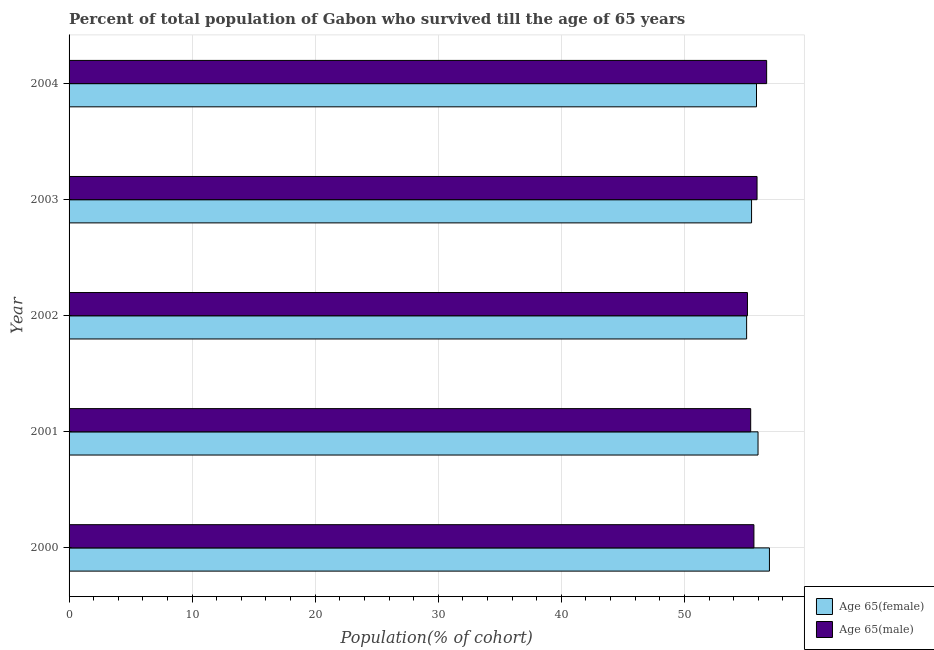How many different coloured bars are there?
Your answer should be compact. 2. How many groups of bars are there?
Provide a succinct answer. 5. Are the number of bars on each tick of the Y-axis equal?
Keep it short and to the point. Yes. How many bars are there on the 2nd tick from the bottom?
Provide a succinct answer. 2. What is the label of the 2nd group of bars from the top?
Give a very brief answer. 2003. In how many cases, is the number of bars for a given year not equal to the number of legend labels?
Provide a short and direct response. 0. What is the percentage of male population who survived till age of 65 in 2001?
Offer a very short reply. 55.39. Across all years, what is the maximum percentage of male population who survived till age of 65?
Offer a very short reply. 56.68. Across all years, what is the minimum percentage of male population who survived till age of 65?
Offer a terse response. 55.13. What is the total percentage of female population who survived till age of 65 in the graph?
Your response must be concise. 279.27. What is the difference between the percentage of male population who survived till age of 65 in 2000 and that in 2002?
Provide a short and direct response. 0.53. What is the difference between the percentage of female population who survived till age of 65 in 2004 and the percentage of male population who survived till age of 65 in 2003?
Your response must be concise. -0.04. What is the average percentage of male population who survived till age of 65 per year?
Your answer should be very brief. 55.75. In the year 2001, what is the difference between the percentage of female population who survived till age of 65 and percentage of male population who survived till age of 65?
Your answer should be very brief. 0.6. What is the ratio of the percentage of male population who survived till age of 65 in 2000 to that in 2004?
Offer a terse response. 0.98. Is the percentage of male population who survived till age of 65 in 2001 less than that in 2004?
Provide a short and direct response. Yes. Is the difference between the percentage of male population who survived till age of 65 in 2001 and 2004 greater than the difference between the percentage of female population who survived till age of 65 in 2001 and 2004?
Ensure brevity in your answer.  No. What is the difference between the highest and the second highest percentage of male population who survived till age of 65?
Your answer should be compact. 0.78. What is the difference between the highest and the lowest percentage of female population who survived till age of 65?
Keep it short and to the point. 1.85. In how many years, is the percentage of female population who survived till age of 65 greater than the average percentage of female population who survived till age of 65 taken over all years?
Your response must be concise. 3. What does the 2nd bar from the top in 2000 represents?
Your answer should be very brief. Age 65(female). What does the 1st bar from the bottom in 2003 represents?
Offer a very short reply. Age 65(female). Are all the bars in the graph horizontal?
Offer a terse response. Yes. What is the difference between two consecutive major ticks on the X-axis?
Make the answer very short. 10. Are the values on the major ticks of X-axis written in scientific E-notation?
Give a very brief answer. No. How many legend labels are there?
Give a very brief answer. 2. What is the title of the graph?
Give a very brief answer. Percent of total population of Gabon who survived till the age of 65 years. Does "State government" appear as one of the legend labels in the graph?
Keep it short and to the point. No. What is the label or title of the X-axis?
Ensure brevity in your answer.  Population(% of cohort). What is the label or title of the Y-axis?
Offer a very short reply. Year. What is the Population(% of cohort) in Age 65(female) in 2000?
Make the answer very short. 56.91. What is the Population(% of cohort) of Age 65(male) in 2000?
Provide a succinct answer. 55.65. What is the Population(% of cohort) of Age 65(female) in 2001?
Offer a terse response. 55.98. What is the Population(% of cohort) of Age 65(male) in 2001?
Ensure brevity in your answer.  55.39. What is the Population(% of cohort) in Age 65(female) in 2002?
Your answer should be compact. 55.06. What is the Population(% of cohort) of Age 65(male) in 2002?
Your answer should be compact. 55.13. What is the Population(% of cohort) in Age 65(female) in 2003?
Make the answer very short. 55.46. What is the Population(% of cohort) of Age 65(male) in 2003?
Ensure brevity in your answer.  55.91. What is the Population(% of cohort) of Age 65(female) in 2004?
Ensure brevity in your answer.  55.86. What is the Population(% of cohort) in Age 65(male) in 2004?
Offer a terse response. 56.68. Across all years, what is the maximum Population(% of cohort) in Age 65(female)?
Ensure brevity in your answer.  56.91. Across all years, what is the maximum Population(% of cohort) of Age 65(male)?
Offer a very short reply. 56.68. Across all years, what is the minimum Population(% of cohort) of Age 65(female)?
Offer a very short reply. 55.06. Across all years, what is the minimum Population(% of cohort) of Age 65(male)?
Provide a succinct answer. 55.13. What is the total Population(% of cohort) of Age 65(female) in the graph?
Offer a very short reply. 279.27. What is the total Population(% of cohort) in Age 65(male) in the graph?
Your response must be concise. 278.75. What is the difference between the Population(% of cohort) in Age 65(female) in 2000 and that in 2001?
Offer a very short reply. 0.93. What is the difference between the Population(% of cohort) in Age 65(male) in 2000 and that in 2001?
Offer a very short reply. 0.26. What is the difference between the Population(% of cohort) of Age 65(female) in 2000 and that in 2002?
Offer a terse response. 1.85. What is the difference between the Population(% of cohort) of Age 65(male) in 2000 and that in 2002?
Your answer should be compact. 0.52. What is the difference between the Population(% of cohort) of Age 65(female) in 2000 and that in 2003?
Offer a terse response. 1.45. What is the difference between the Population(% of cohort) of Age 65(male) in 2000 and that in 2003?
Your answer should be very brief. -0.25. What is the difference between the Population(% of cohort) of Age 65(female) in 2000 and that in 2004?
Your answer should be compact. 1.05. What is the difference between the Population(% of cohort) in Age 65(male) in 2000 and that in 2004?
Provide a succinct answer. -1.03. What is the difference between the Population(% of cohort) in Age 65(female) in 2001 and that in 2002?
Make the answer very short. 0.93. What is the difference between the Population(% of cohort) in Age 65(male) in 2001 and that in 2002?
Keep it short and to the point. 0.26. What is the difference between the Population(% of cohort) of Age 65(female) in 2001 and that in 2003?
Your answer should be very brief. 0.53. What is the difference between the Population(% of cohort) in Age 65(male) in 2001 and that in 2003?
Your response must be concise. -0.52. What is the difference between the Population(% of cohort) of Age 65(female) in 2001 and that in 2004?
Provide a short and direct response. 0.12. What is the difference between the Population(% of cohort) in Age 65(male) in 2001 and that in 2004?
Keep it short and to the point. -1.3. What is the difference between the Population(% of cohort) of Age 65(female) in 2002 and that in 2003?
Your response must be concise. -0.4. What is the difference between the Population(% of cohort) of Age 65(male) in 2002 and that in 2003?
Give a very brief answer. -0.78. What is the difference between the Population(% of cohort) of Age 65(female) in 2002 and that in 2004?
Offer a very short reply. -0.8. What is the difference between the Population(% of cohort) of Age 65(male) in 2002 and that in 2004?
Your response must be concise. -1.56. What is the difference between the Population(% of cohort) in Age 65(female) in 2003 and that in 2004?
Your response must be concise. -0.4. What is the difference between the Population(% of cohort) of Age 65(male) in 2003 and that in 2004?
Make the answer very short. -0.78. What is the difference between the Population(% of cohort) in Age 65(female) in 2000 and the Population(% of cohort) in Age 65(male) in 2001?
Provide a short and direct response. 1.52. What is the difference between the Population(% of cohort) in Age 65(female) in 2000 and the Population(% of cohort) in Age 65(male) in 2002?
Keep it short and to the point. 1.79. What is the difference between the Population(% of cohort) in Age 65(female) in 2000 and the Population(% of cohort) in Age 65(male) in 2004?
Your response must be concise. 0.23. What is the difference between the Population(% of cohort) of Age 65(female) in 2001 and the Population(% of cohort) of Age 65(male) in 2002?
Your response must be concise. 0.86. What is the difference between the Population(% of cohort) in Age 65(female) in 2001 and the Population(% of cohort) in Age 65(male) in 2003?
Your answer should be compact. 0.08. What is the difference between the Population(% of cohort) of Age 65(female) in 2001 and the Population(% of cohort) of Age 65(male) in 2004?
Your answer should be compact. -0.7. What is the difference between the Population(% of cohort) of Age 65(female) in 2002 and the Population(% of cohort) of Age 65(male) in 2003?
Provide a succinct answer. -0.85. What is the difference between the Population(% of cohort) of Age 65(female) in 2002 and the Population(% of cohort) of Age 65(male) in 2004?
Your answer should be compact. -1.63. What is the difference between the Population(% of cohort) of Age 65(female) in 2003 and the Population(% of cohort) of Age 65(male) in 2004?
Your answer should be very brief. -1.23. What is the average Population(% of cohort) in Age 65(female) per year?
Offer a terse response. 55.85. What is the average Population(% of cohort) of Age 65(male) per year?
Give a very brief answer. 55.75. In the year 2000, what is the difference between the Population(% of cohort) of Age 65(female) and Population(% of cohort) of Age 65(male)?
Provide a short and direct response. 1.26. In the year 2001, what is the difference between the Population(% of cohort) in Age 65(female) and Population(% of cohort) in Age 65(male)?
Make the answer very short. 0.6. In the year 2002, what is the difference between the Population(% of cohort) of Age 65(female) and Population(% of cohort) of Age 65(male)?
Your answer should be very brief. -0.07. In the year 2003, what is the difference between the Population(% of cohort) of Age 65(female) and Population(% of cohort) of Age 65(male)?
Keep it short and to the point. -0.45. In the year 2004, what is the difference between the Population(% of cohort) in Age 65(female) and Population(% of cohort) in Age 65(male)?
Your answer should be very brief. -0.82. What is the ratio of the Population(% of cohort) in Age 65(female) in 2000 to that in 2001?
Provide a succinct answer. 1.02. What is the ratio of the Population(% of cohort) in Age 65(female) in 2000 to that in 2002?
Provide a short and direct response. 1.03. What is the ratio of the Population(% of cohort) in Age 65(male) in 2000 to that in 2002?
Ensure brevity in your answer.  1.01. What is the ratio of the Population(% of cohort) of Age 65(female) in 2000 to that in 2003?
Your answer should be compact. 1.03. What is the ratio of the Population(% of cohort) in Age 65(male) in 2000 to that in 2003?
Your answer should be compact. 1. What is the ratio of the Population(% of cohort) of Age 65(female) in 2000 to that in 2004?
Make the answer very short. 1.02. What is the ratio of the Population(% of cohort) of Age 65(male) in 2000 to that in 2004?
Keep it short and to the point. 0.98. What is the ratio of the Population(% of cohort) in Age 65(female) in 2001 to that in 2002?
Offer a very short reply. 1.02. What is the ratio of the Population(% of cohort) of Age 65(female) in 2001 to that in 2003?
Keep it short and to the point. 1.01. What is the ratio of the Population(% of cohort) of Age 65(male) in 2001 to that in 2003?
Your answer should be compact. 0.99. What is the ratio of the Population(% of cohort) of Age 65(male) in 2001 to that in 2004?
Make the answer very short. 0.98. What is the ratio of the Population(% of cohort) of Age 65(female) in 2002 to that in 2003?
Provide a succinct answer. 0.99. What is the ratio of the Population(% of cohort) of Age 65(male) in 2002 to that in 2003?
Your response must be concise. 0.99. What is the ratio of the Population(% of cohort) in Age 65(female) in 2002 to that in 2004?
Your response must be concise. 0.99. What is the ratio of the Population(% of cohort) in Age 65(male) in 2002 to that in 2004?
Ensure brevity in your answer.  0.97. What is the ratio of the Population(% of cohort) of Age 65(male) in 2003 to that in 2004?
Give a very brief answer. 0.99. What is the difference between the highest and the second highest Population(% of cohort) in Age 65(female)?
Provide a succinct answer. 0.93. What is the difference between the highest and the second highest Population(% of cohort) in Age 65(male)?
Your answer should be compact. 0.78. What is the difference between the highest and the lowest Population(% of cohort) of Age 65(female)?
Offer a very short reply. 1.85. What is the difference between the highest and the lowest Population(% of cohort) in Age 65(male)?
Give a very brief answer. 1.56. 